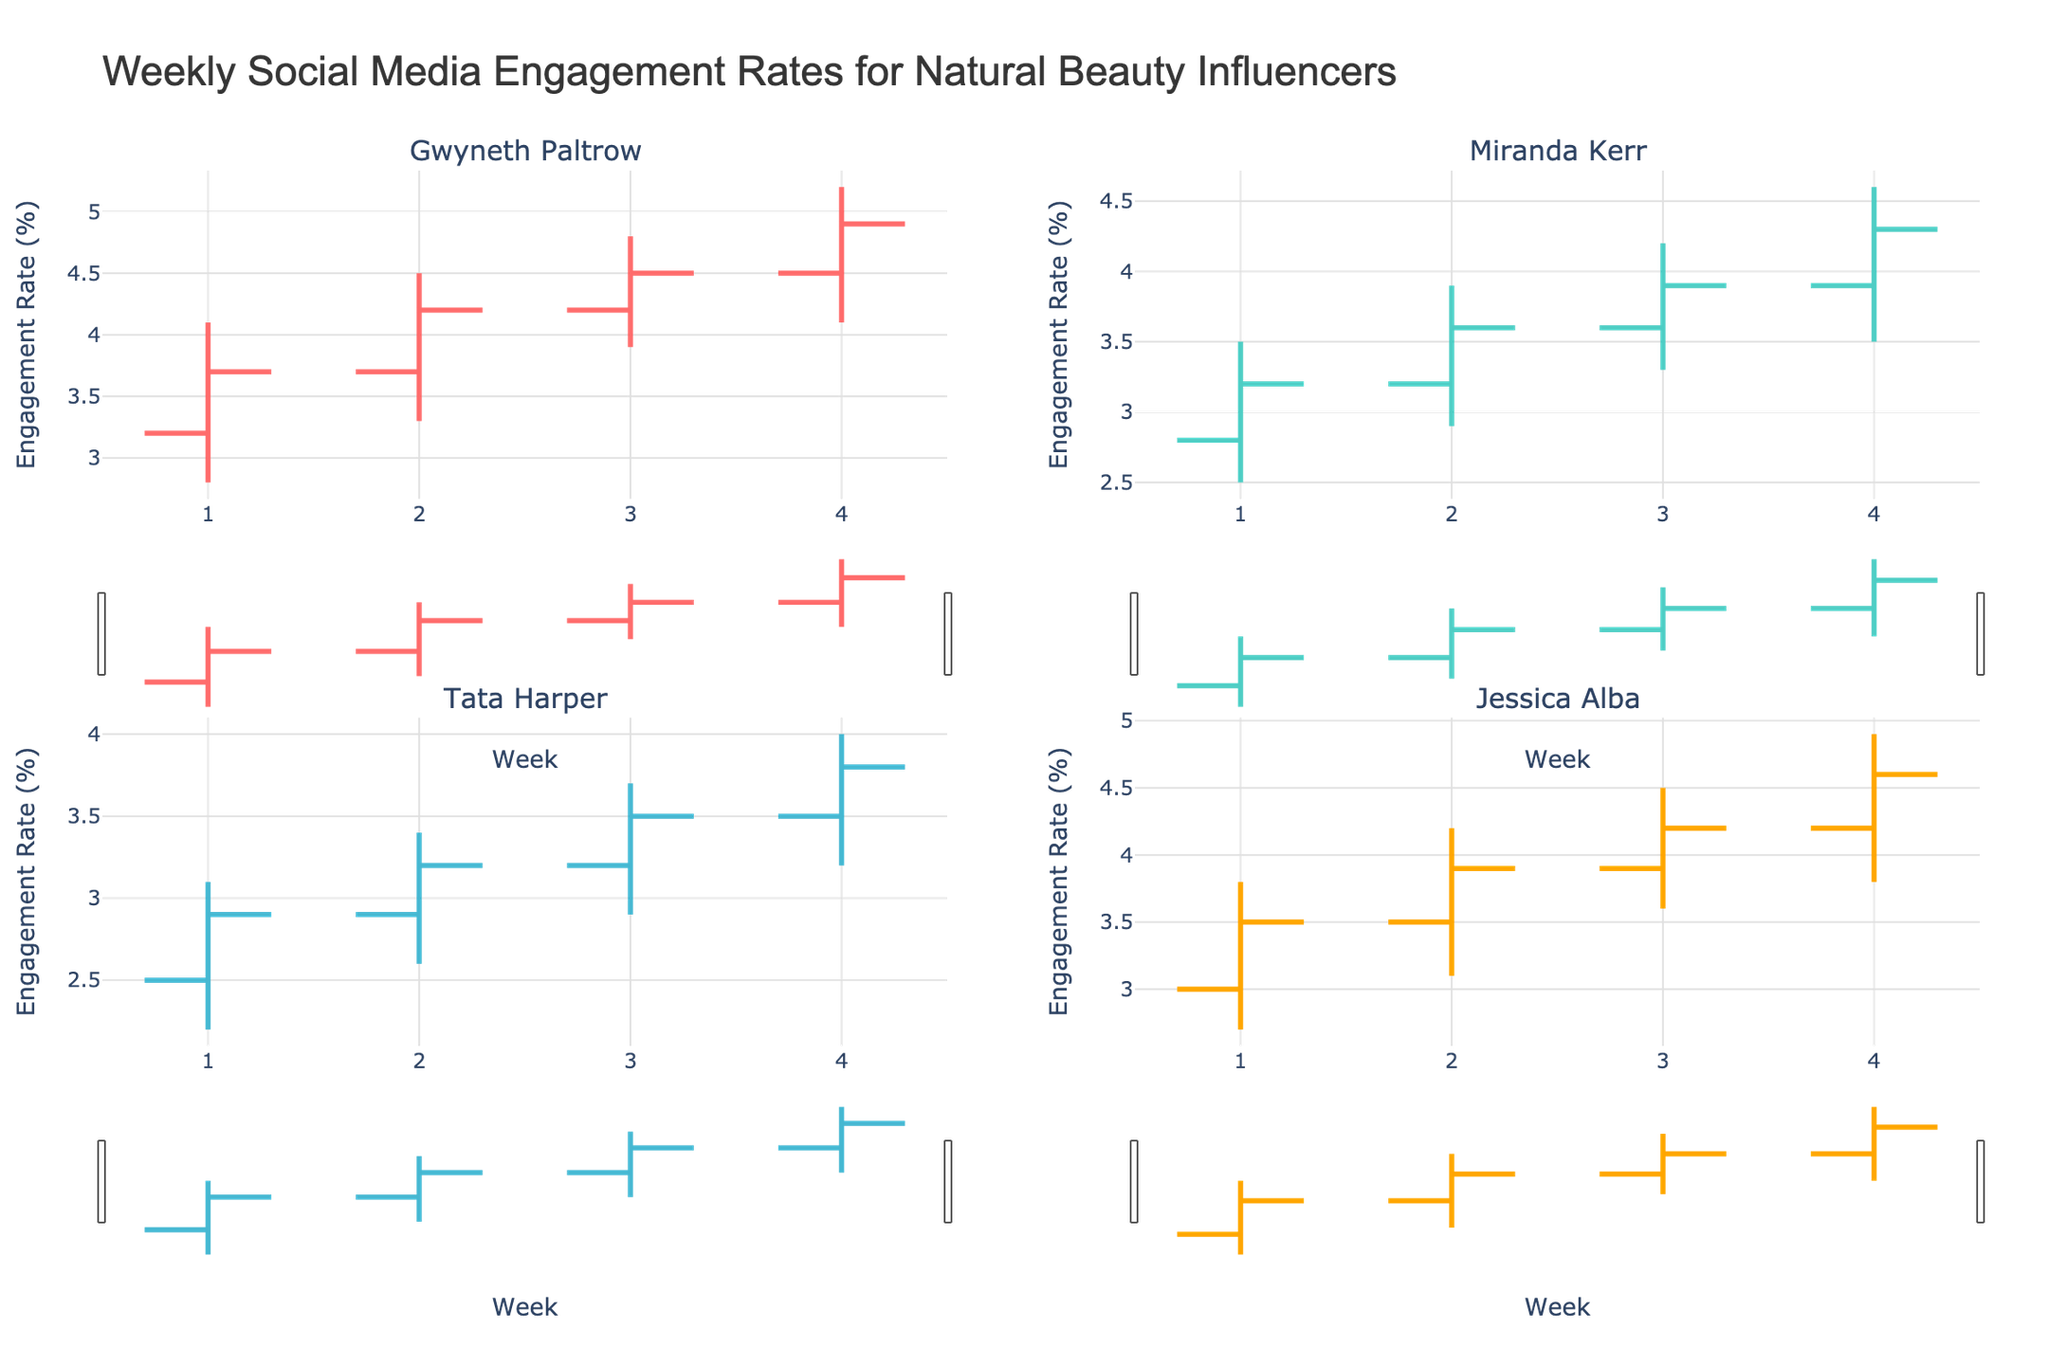Which influencer had the highest engagement rate in the fourth week? From the fourth-week data, look at the "High" values in each subplot. Gwyneth Paltrow has the highest value of 5.2.
Answer: Gwyneth Paltrow What is the title of the figure? The title is displayed at the top of the figure.
Answer: Weekly Social Media Engagement Rates for Natural Beauty Influencers Which influencer had the most consistent engagement rates over the four weeks? Compare the "Open" and "Close" values for each influencer across the weeks. The smallest fluctuations can indicate consistency. Gwyneth Paltrow's changes are mostly within a smaller range.
Answer: Gwyneth Paltrow How did Miranda Kerr's engagement rate change from the first week to the last week? Compare the "Open" of week 1 and "Close" of week 4 for Miranda Kerr. Week 1's open is 2.8 and Week 4's close is 4.3.
Answer: Increased What is the average of the highest engagement rates recorded for Jessica Alba over four weeks? Add the "High" values across all four weeks, then divide by 4. (3.8 + 4.2 + 4.5 + 4.9) / 4 = 4.35.
Answer: 4.35 Which influencer experienced the highest drop in engagement rate within a week? Calculate the difference between "High" and "Low" for each influencer across all weeks and identify the largest drop. Tata Harper's week 1 drop is the highest (3.1 - 2.2 = 0.9).
Answer: Tata Harper What were the engagement rate ranges for Tata Harper in the third week? Look at Tata Harper's data for week 3: "Low" is 2.9 and "High" is 3.7. The range is 3.7 - 2.9 = 0.8.
Answer: 0.8 Which influencer had the highest opening engagement rate in the first week? Look at the "Open" values for each influencer in the first week. Gwyneth Paltrow's opening engagement rate is the highest at 3.2.
Answer: Gwyneth Paltrow How do the opening engagement rates for Gwyneth Paltrow and Jessica Alba in the second week compare? By checking the "Open" values for Gwyneth Paltrow and Jessica Alba in the second week, Gwyneth Paltrow has 3.7 and Jessica Alba has 3.5.
Answer: Gwyneth Paltrow's is higher 